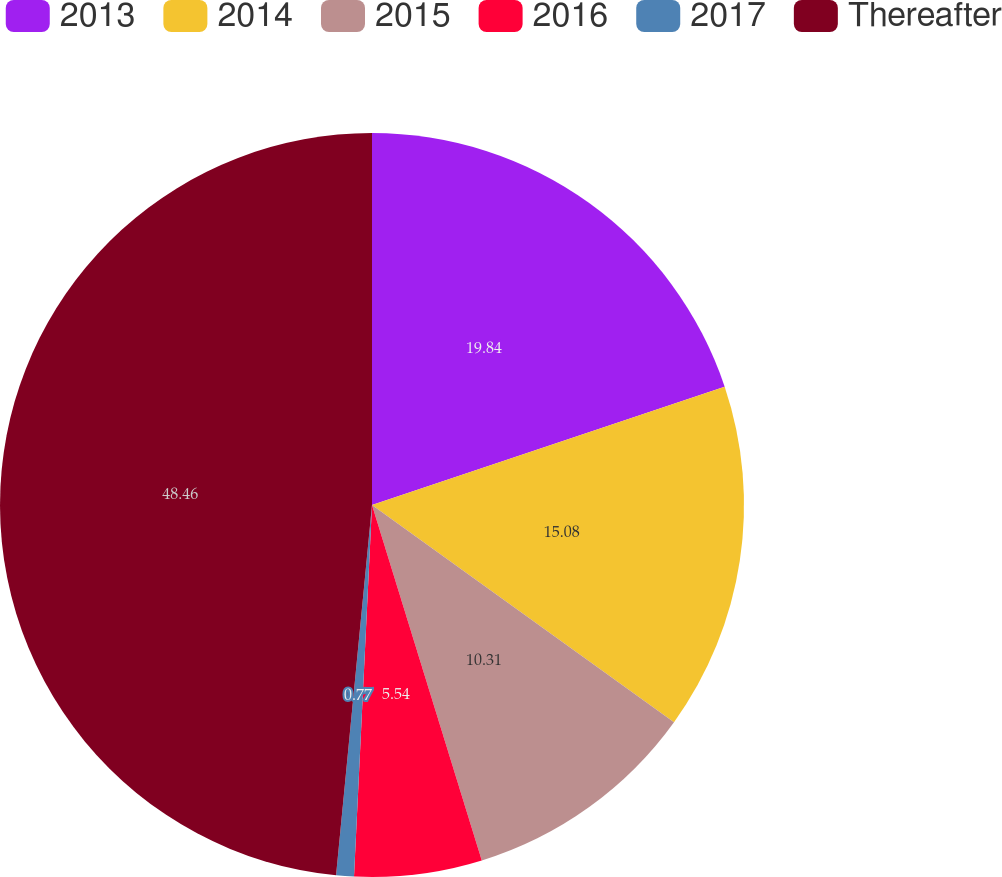Convert chart. <chart><loc_0><loc_0><loc_500><loc_500><pie_chart><fcel>2013<fcel>2014<fcel>2015<fcel>2016<fcel>2017<fcel>Thereafter<nl><fcel>19.85%<fcel>15.08%<fcel>10.31%<fcel>5.54%<fcel>0.77%<fcel>48.47%<nl></chart> 